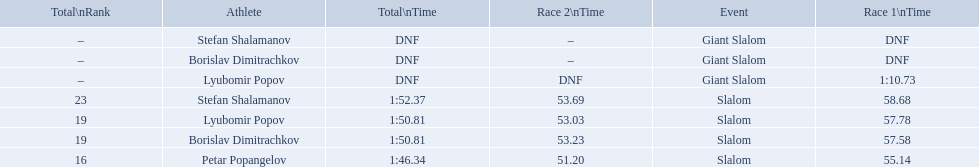Which event is the giant slalom? Giant Slalom, Giant Slalom, Giant Slalom. Which one is lyubomir popov? Lyubomir Popov. What is race 1 tim? 1:10.73. 